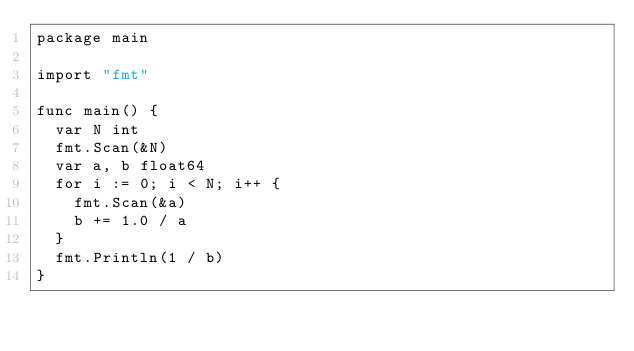Convert code to text. <code><loc_0><loc_0><loc_500><loc_500><_Go_>package main

import "fmt"

func main() {
	var N int
	fmt.Scan(&N)
	var a, b float64
	for i := 0; i < N; i++ {
		fmt.Scan(&a)
		b += 1.0 / a
	}
	fmt.Println(1 / b)
}
</code> 